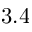<formula> <loc_0><loc_0><loc_500><loc_500>3 . 4</formula> 